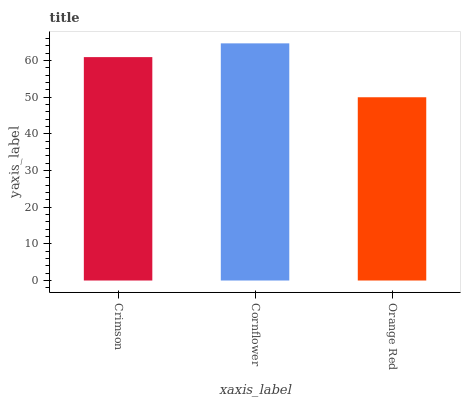Is Orange Red the minimum?
Answer yes or no. Yes. Is Cornflower the maximum?
Answer yes or no. Yes. Is Cornflower the minimum?
Answer yes or no. No. Is Orange Red the maximum?
Answer yes or no. No. Is Cornflower greater than Orange Red?
Answer yes or no. Yes. Is Orange Red less than Cornflower?
Answer yes or no. Yes. Is Orange Red greater than Cornflower?
Answer yes or no. No. Is Cornflower less than Orange Red?
Answer yes or no. No. Is Crimson the high median?
Answer yes or no. Yes. Is Crimson the low median?
Answer yes or no. Yes. Is Cornflower the high median?
Answer yes or no. No. Is Orange Red the low median?
Answer yes or no. No. 